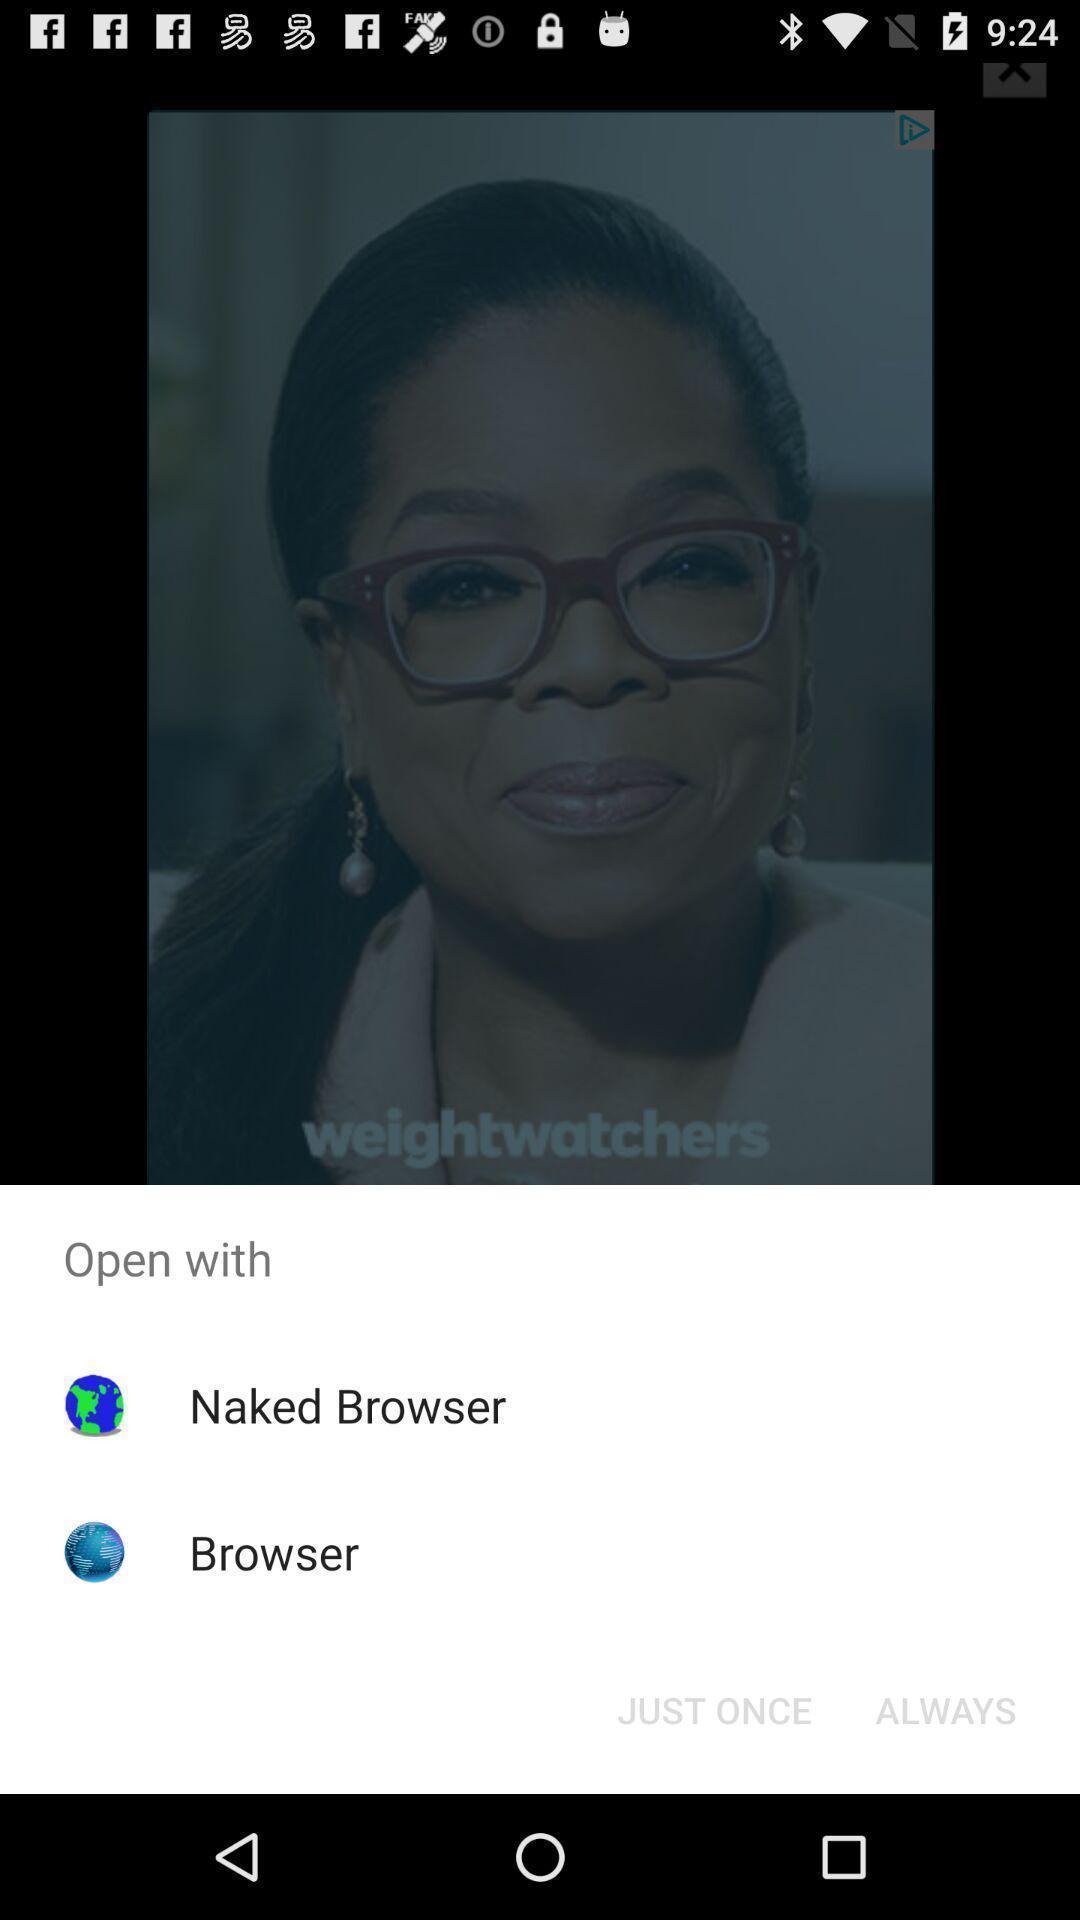Describe this image in words. Popup showing applications to open a file with. 